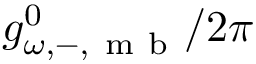Convert formula to latex. <formula><loc_0><loc_0><loc_500><loc_500>g _ { \omega , - , m b } ^ { 0 } / 2 \pi</formula> 